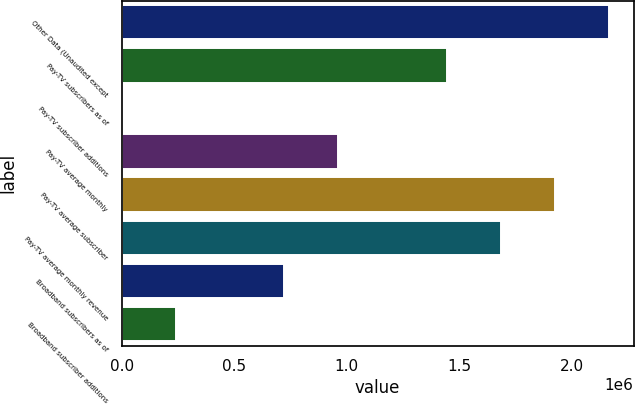Convert chart. <chart><loc_0><loc_0><loc_500><loc_500><bar_chart><fcel>Other Data (Unaudited except<fcel>Pay-TV subscribers as of<fcel>Pay-TV subscriber additions<fcel>Pay-TV average monthly<fcel>Pay-TV average subscriber<fcel>Pay-TV average monthly revenue<fcel>Broadband subscribers as of<fcel>Broadband subscriber additions<nl><fcel>2.16732e+06<fcel>1.44488e+06<fcel>0.08<fcel>963252<fcel>1.9265e+06<fcel>1.68569e+06<fcel>722439<fcel>240813<nl></chart> 